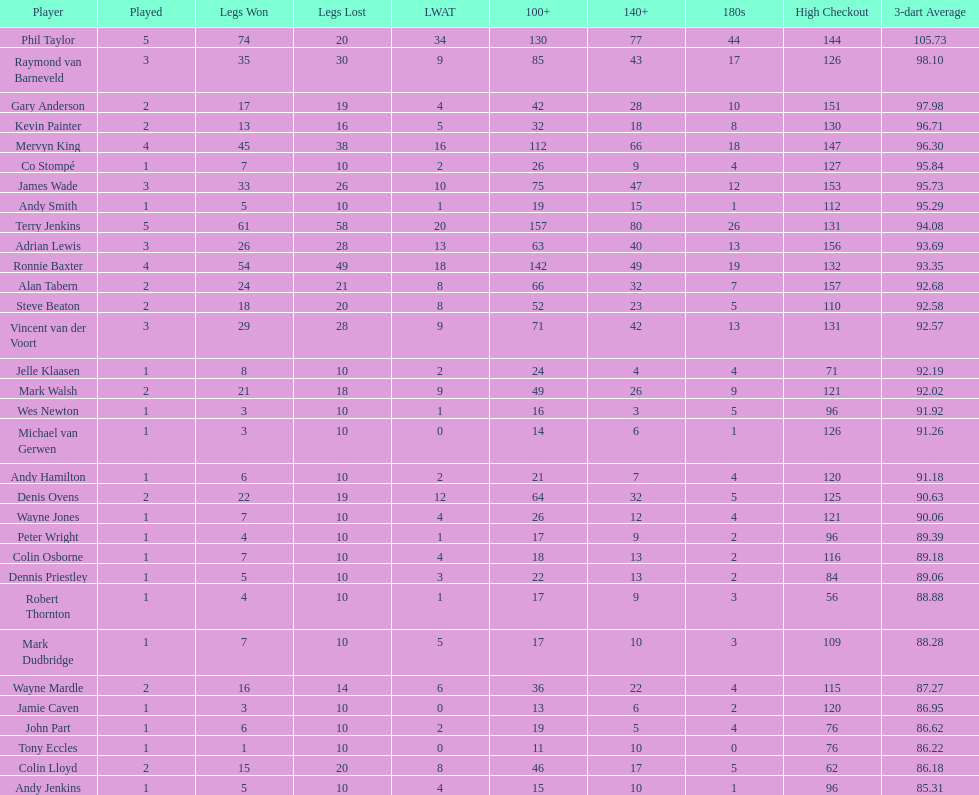Mark walsh's average is above/below 93? Below. 